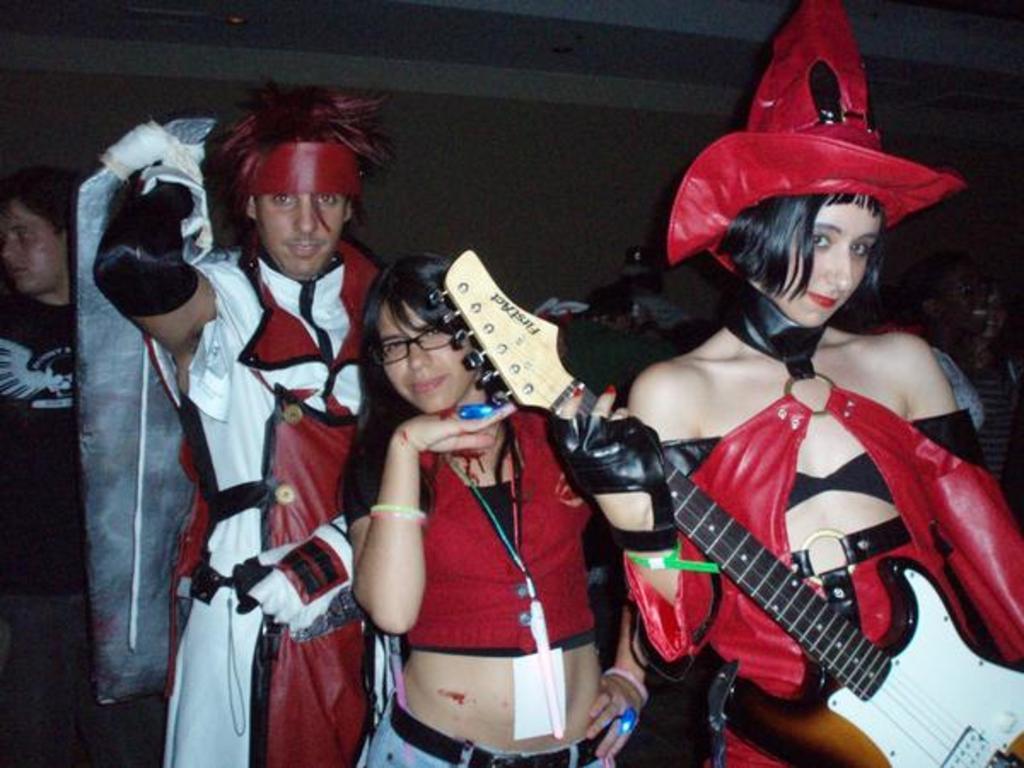Can you describe this image briefly? There are people in this image. In the front there are three people who are wearing red and black dress. In that one is one man and two are women. The one who is on the right side is holding guitar. The one who is in the back side is holding some board. 